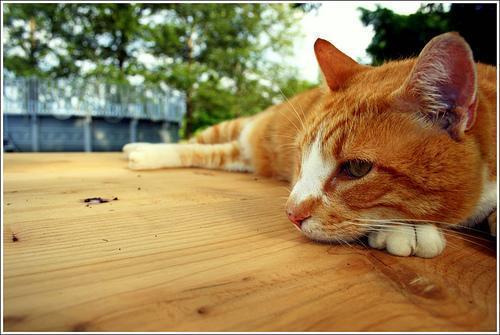How many cats are there?
Give a very brief answer. 1. How many animals in the picture?
Give a very brief answer. 1. 